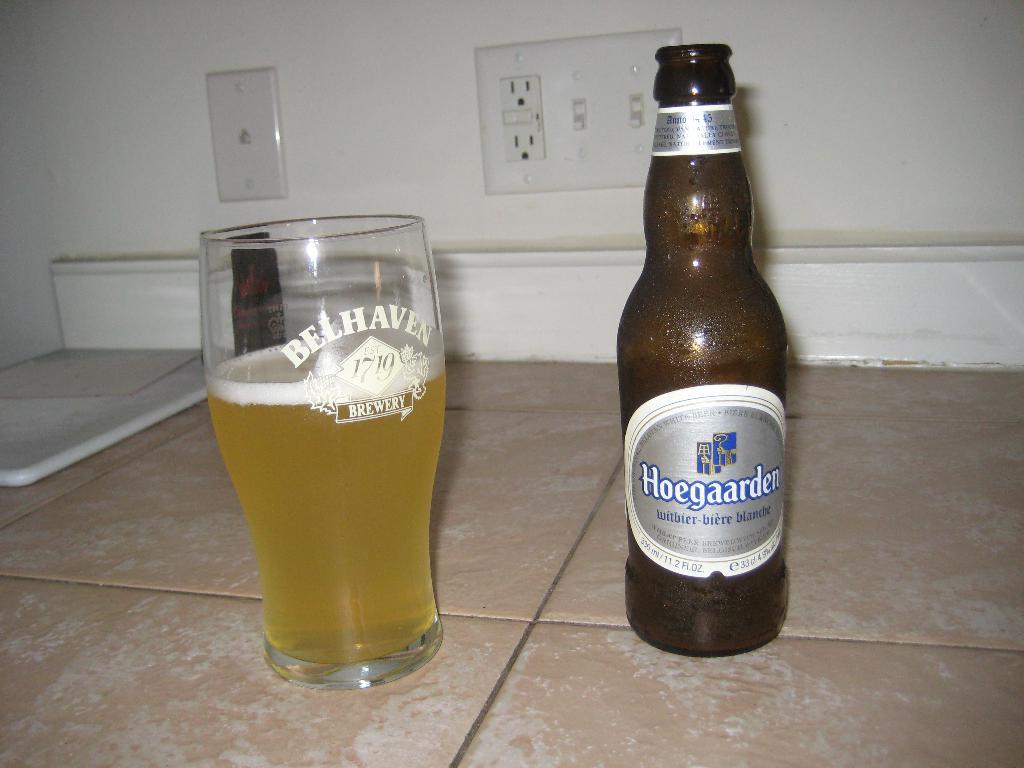Provide a one-sentence caption for the provided image. A Hoegaarden witbier-biere blanche beer and a glass beside it. 